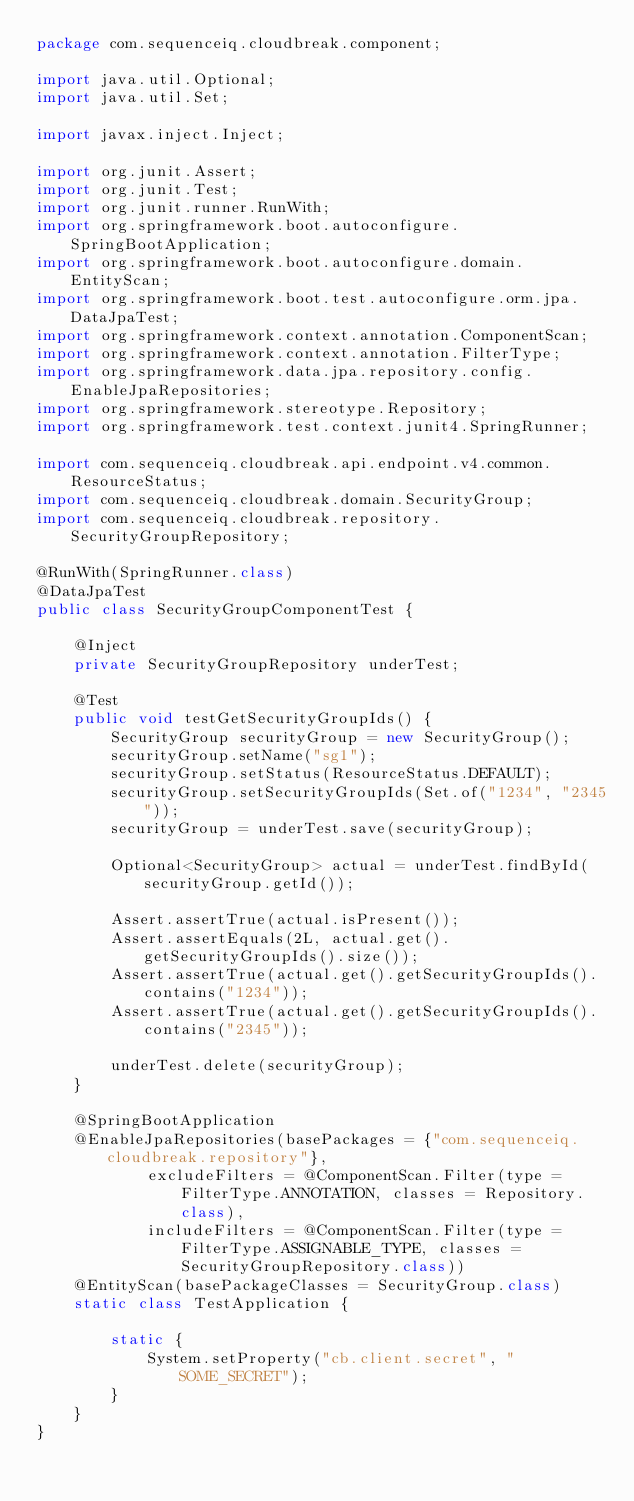<code> <loc_0><loc_0><loc_500><loc_500><_Java_>package com.sequenceiq.cloudbreak.component;

import java.util.Optional;
import java.util.Set;

import javax.inject.Inject;

import org.junit.Assert;
import org.junit.Test;
import org.junit.runner.RunWith;
import org.springframework.boot.autoconfigure.SpringBootApplication;
import org.springframework.boot.autoconfigure.domain.EntityScan;
import org.springframework.boot.test.autoconfigure.orm.jpa.DataJpaTest;
import org.springframework.context.annotation.ComponentScan;
import org.springframework.context.annotation.FilterType;
import org.springframework.data.jpa.repository.config.EnableJpaRepositories;
import org.springframework.stereotype.Repository;
import org.springframework.test.context.junit4.SpringRunner;

import com.sequenceiq.cloudbreak.api.endpoint.v4.common.ResourceStatus;
import com.sequenceiq.cloudbreak.domain.SecurityGroup;
import com.sequenceiq.cloudbreak.repository.SecurityGroupRepository;

@RunWith(SpringRunner.class)
@DataJpaTest
public class SecurityGroupComponentTest {

    @Inject
    private SecurityGroupRepository underTest;

    @Test
    public void testGetSecurityGroupIds() {
        SecurityGroup securityGroup = new SecurityGroup();
        securityGroup.setName("sg1");
        securityGroup.setStatus(ResourceStatus.DEFAULT);
        securityGroup.setSecurityGroupIds(Set.of("1234", "2345"));
        securityGroup = underTest.save(securityGroup);

        Optional<SecurityGroup> actual = underTest.findById(securityGroup.getId());

        Assert.assertTrue(actual.isPresent());
        Assert.assertEquals(2L, actual.get().getSecurityGroupIds().size());
        Assert.assertTrue(actual.get().getSecurityGroupIds().contains("1234"));
        Assert.assertTrue(actual.get().getSecurityGroupIds().contains("2345"));

        underTest.delete(securityGroup);
    }

    @SpringBootApplication
    @EnableJpaRepositories(basePackages = {"com.sequenceiq.cloudbreak.repository"},
            excludeFilters = @ComponentScan.Filter(type = FilterType.ANNOTATION, classes = Repository.class),
            includeFilters = @ComponentScan.Filter(type = FilterType.ASSIGNABLE_TYPE, classes = SecurityGroupRepository.class))
    @EntityScan(basePackageClasses = SecurityGroup.class)
    static class TestApplication {

        static {
            System.setProperty("cb.client.secret", "SOME_SECRET");
        }
    }
}
</code> 